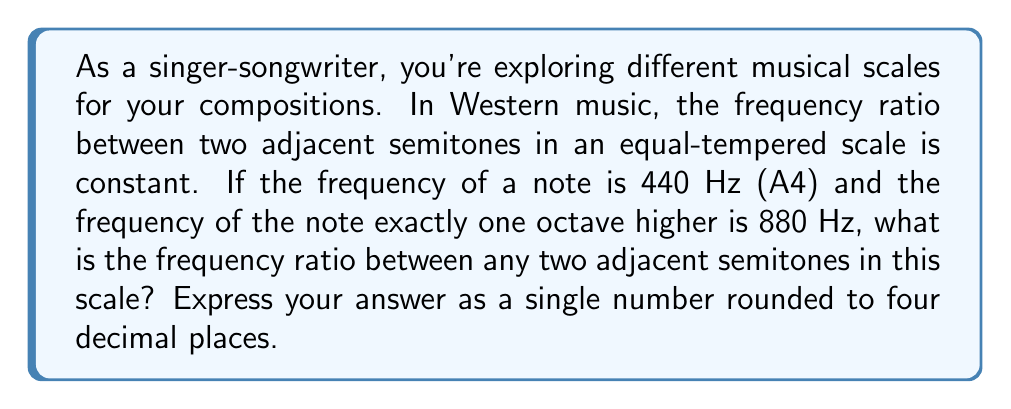What is the answer to this math problem? To solve this problem, we need to understand the relationship between octaves and semitones:

1) An octave represents a doubling of frequency. In this case, we're going from 440 Hz to 880 Hz.

2) In Western music, an octave is divided into 12 semitones in the equal-tempered scale.

3) The frequency ratio between any two adjacent semitones is constant. Let's call this ratio $r$.

4) Since there are 12 semitones in an octave, we can express the octave ratio as $r^{12}$.

5) We know that the octave ratio is 2 (880 Hz / 440 Hz = 2), so we can set up the equation:

   $$r^{12} = 2$$

6) To solve for $r$, we take the 12th root of both sides:

   $$r = \sqrt[12]{2}$$

7) Using a calculator or computer, we can compute this value:

   $$r \approx 1.0594630943592953$$

8) Rounding to four decimal places gives us 1.0595.

This ratio, approximately 1.0595, is the frequency ratio between any two adjacent semitones in the equal-tempered scale.
Answer: 1.0595 